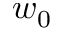<formula> <loc_0><loc_0><loc_500><loc_500>w _ { 0 }</formula> 